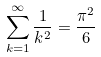<formula> <loc_0><loc_0><loc_500><loc_500>\sum _ { k = 1 } ^ { \infty } \frac { 1 } { k ^ { 2 } } = \frac { \pi ^ { 2 } } { 6 }</formula> 